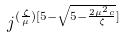Convert formula to latex. <formula><loc_0><loc_0><loc_500><loc_500>j ^ { ( \frac { \zeta } { \mu } ) [ 5 - \sqrt { 5 - \frac { 2 \mu ^ { 2 } c } { \zeta } } ] }</formula> 